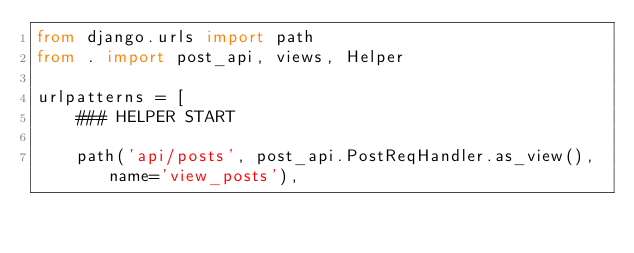<code> <loc_0><loc_0><loc_500><loc_500><_Python_>from django.urls import path
from . import post_api, views, Helper

urlpatterns = [
    ### HELPER START

    path('api/posts', post_api.PostReqHandler.as_view(), name='view_posts'),</code> 